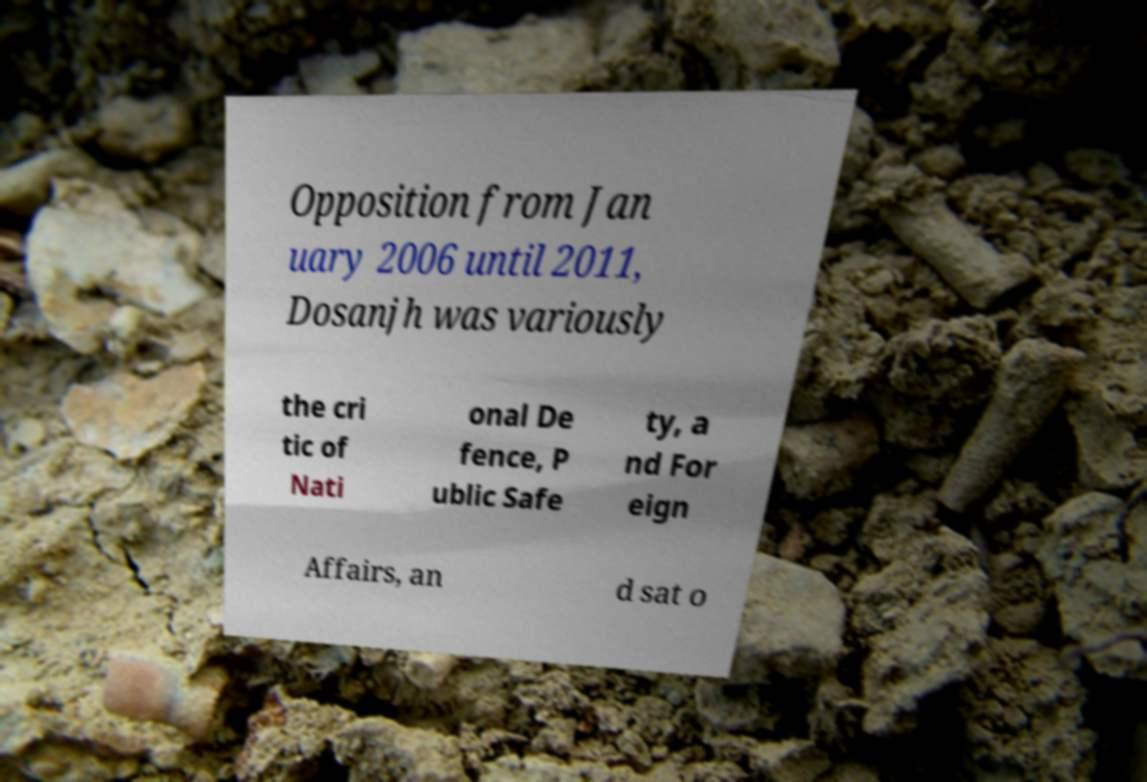For documentation purposes, I need the text within this image transcribed. Could you provide that? Opposition from Jan uary 2006 until 2011, Dosanjh was variously the cri tic of Nati onal De fence, P ublic Safe ty, a nd For eign Affairs, an d sat o 